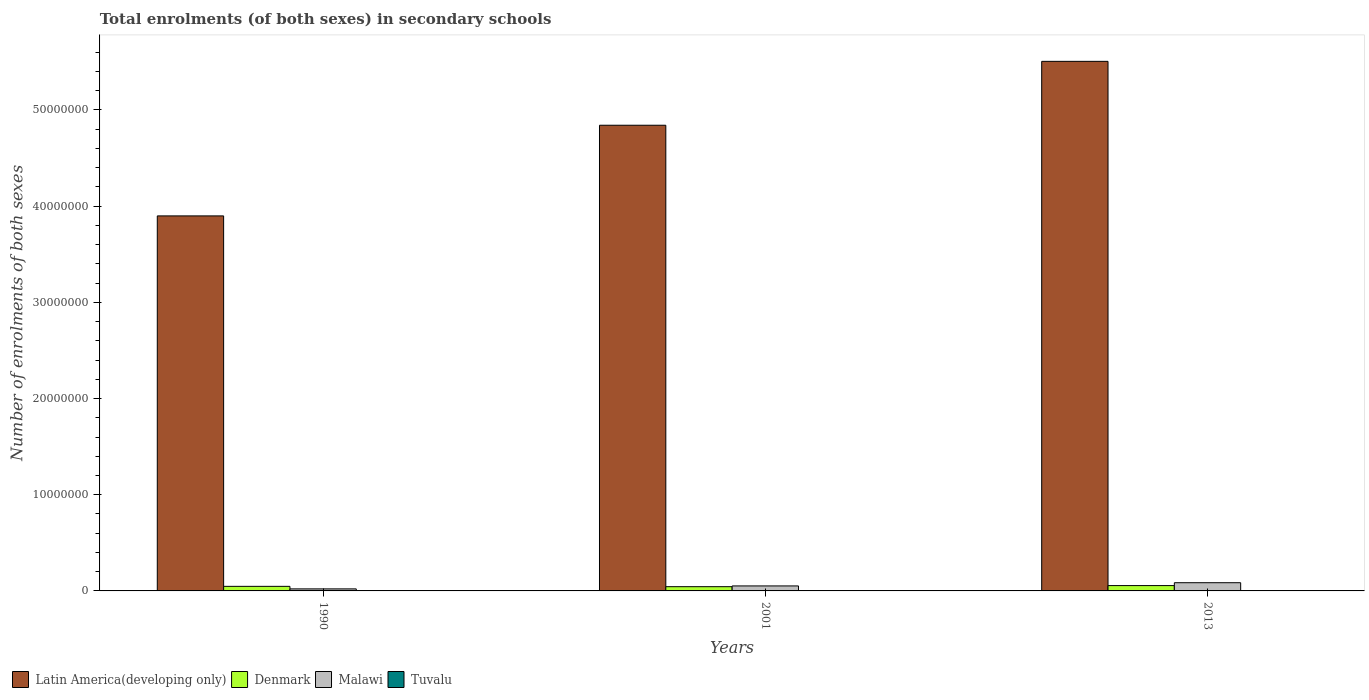How many different coloured bars are there?
Keep it short and to the point. 4. Are the number of bars on each tick of the X-axis equal?
Keep it short and to the point. Yes. How many bars are there on the 2nd tick from the left?
Keep it short and to the point. 4. How many bars are there on the 2nd tick from the right?
Your response must be concise. 4. What is the label of the 2nd group of bars from the left?
Offer a terse response. 2001. What is the number of enrolments in secondary schools in Malawi in 2001?
Provide a short and direct response. 5.18e+05. Across all years, what is the maximum number of enrolments in secondary schools in Malawi?
Offer a very short reply. 8.53e+05. Across all years, what is the minimum number of enrolments in secondary schools in Malawi?
Provide a succinct answer. 2.12e+05. In which year was the number of enrolments in secondary schools in Malawi minimum?
Make the answer very short. 1990. What is the total number of enrolments in secondary schools in Denmark in the graph?
Ensure brevity in your answer.  1.47e+06. What is the difference between the number of enrolments in secondary schools in Malawi in 1990 and that in 2013?
Keep it short and to the point. -6.41e+05. What is the difference between the number of enrolments in secondary schools in Denmark in 2001 and the number of enrolments in secondary schools in Malawi in 1990?
Offer a terse response. 2.29e+05. What is the average number of enrolments in secondary schools in Tuvalu per year?
Keep it short and to the point. 915.33. In the year 1990, what is the difference between the number of enrolments in secondary schools in Tuvalu and number of enrolments in secondary schools in Denmark?
Ensure brevity in your answer.  -4.74e+05. In how many years, is the number of enrolments in secondary schools in Denmark greater than 38000000?
Provide a succinct answer. 0. What is the ratio of the number of enrolments in secondary schools in Malawi in 2001 to that in 2013?
Provide a succinct answer. 0.61. What is the difference between the highest and the second highest number of enrolments in secondary schools in Latin America(developing only)?
Give a very brief answer. 6.64e+06. What is the difference between the highest and the lowest number of enrolments in secondary schools in Malawi?
Make the answer very short. 6.41e+05. In how many years, is the number of enrolments in secondary schools in Tuvalu greater than the average number of enrolments in secondary schools in Tuvalu taken over all years?
Provide a short and direct response. 1. What does the 4th bar from the right in 1990 represents?
Make the answer very short. Latin America(developing only). Is it the case that in every year, the sum of the number of enrolments in secondary schools in Latin America(developing only) and number of enrolments in secondary schools in Malawi is greater than the number of enrolments in secondary schools in Denmark?
Provide a succinct answer. Yes. How many years are there in the graph?
Your answer should be very brief. 3. What is the difference between two consecutive major ticks on the Y-axis?
Offer a terse response. 1.00e+07. Are the values on the major ticks of Y-axis written in scientific E-notation?
Offer a terse response. No. Does the graph contain any zero values?
Your answer should be very brief. No. Does the graph contain grids?
Give a very brief answer. No. Where does the legend appear in the graph?
Make the answer very short. Bottom left. How are the legend labels stacked?
Your response must be concise. Horizontal. What is the title of the graph?
Offer a terse response. Total enrolments (of both sexes) in secondary schools. What is the label or title of the X-axis?
Offer a terse response. Years. What is the label or title of the Y-axis?
Give a very brief answer. Number of enrolments of both sexes. What is the Number of enrolments of both sexes of Latin America(developing only) in 1990?
Provide a short and direct response. 3.90e+07. What is the Number of enrolments of both sexes in Denmark in 1990?
Ensure brevity in your answer.  4.75e+05. What is the Number of enrolments of both sexes of Malawi in 1990?
Keep it short and to the point. 2.12e+05. What is the Number of enrolments of both sexes of Tuvalu in 1990?
Your answer should be very brief. 625. What is the Number of enrolments of both sexes in Latin America(developing only) in 2001?
Make the answer very short. 4.84e+07. What is the Number of enrolments of both sexes in Denmark in 2001?
Keep it short and to the point. 4.42e+05. What is the Number of enrolments of both sexes of Malawi in 2001?
Provide a succinct answer. 5.18e+05. What is the Number of enrolments of both sexes in Tuvalu in 2001?
Give a very brief answer. 912. What is the Number of enrolments of both sexes in Latin America(developing only) in 2013?
Keep it short and to the point. 5.51e+07. What is the Number of enrolments of both sexes of Denmark in 2013?
Make the answer very short. 5.55e+05. What is the Number of enrolments of both sexes in Malawi in 2013?
Ensure brevity in your answer.  8.53e+05. What is the Number of enrolments of both sexes in Tuvalu in 2013?
Provide a succinct answer. 1209. Across all years, what is the maximum Number of enrolments of both sexes in Latin America(developing only)?
Ensure brevity in your answer.  5.51e+07. Across all years, what is the maximum Number of enrolments of both sexes of Denmark?
Provide a succinct answer. 5.55e+05. Across all years, what is the maximum Number of enrolments of both sexes of Malawi?
Your response must be concise. 8.53e+05. Across all years, what is the maximum Number of enrolments of both sexes of Tuvalu?
Give a very brief answer. 1209. Across all years, what is the minimum Number of enrolments of both sexes of Latin America(developing only)?
Ensure brevity in your answer.  3.90e+07. Across all years, what is the minimum Number of enrolments of both sexes of Denmark?
Your response must be concise. 4.42e+05. Across all years, what is the minimum Number of enrolments of both sexes in Malawi?
Your response must be concise. 2.12e+05. Across all years, what is the minimum Number of enrolments of both sexes of Tuvalu?
Provide a succinct answer. 625. What is the total Number of enrolments of both sexes in Latin America(developing only) in the graph?
Give a very brief answer. 1.42e+08. What is the total Number of enrolments of both sexes in Denmark in the graph?
Give a very brief answer. 1.47e+06. What is the total Number of enrolments of both sexes of Malawi in the graph?
Provide a short and direct response. 1.58e+06. What is the total Number of enrolments of both sexes in Tuvalu in the graph?
Your response must be concise. 2746. What is the difference between the Number of enrolments of both sexes of Latin America(developing only) in 1990 and that in 2001?
Your response must be concise. -9.42e+06. What is the difference between the Number of enrolments of both sexes of Denmark in 1990 and that in 2001?
Give a very brief answer. 3.34e+04. What is the difference between the Number of enrolments of both sexes in Malawi in 1990 and that in 2001?
Ensure brevity in your answer.  -3.06e+05. What is the difference between the Number of enrolments of both sexes of Tuvalu in 1990 and that in 2001?
Provide a succinct answer. -287. What is the difference between the Number of enrolments of both sexes in Latin America(developing only) in 1990 and that in 2013?
Your response must be concise. -1.61e+07. What is the difference between the Number of enrolments of both sexes in Denmark in 1990 and that in 2013?
Provide a short and direct response. -8.04e+04. What is the difference between the Number of enrolments of both sexes in Malawi in 1990 and that in 2013?
Keep it short and to the point. -6.41e+05. What is the difference between the Number of enrolments of both sexes in Tuvalu in 1990 and that in 2013?
Offer a very short reply. -584. What is the difference between the Number of enrolments of both sexes in Latin America(developing only) in 2001 and that in 2013?
Give a very brief answer. -6.64e+06. What is the difference between the Number of enrolments of both sexes of Denmark in 2001 and that in 2013?
Offer a terse response. -1.14e+05. What is the difference between the Number of enrolments of both sexes of Malawi in 2001 and that in 2013?
Your answer should be compact. -3.35e+05. What is the difference between the Number of enrolments of both sexes in Tuvalu in 2001 and that in 2013?
Your response must be concise. -297. What is the difference between the Number of enrolments of both sexes of Latin America(developing only) in 1990 and the Number of enrolments of both sexes of Denmark in 2001?
Offer a very short reply. 3.85e+07. What is the difference between the Number of enrolments of both sexes of Latin America(developing only) in 1990 and the Number of enrolments of both sexes of Malawi in 2001?
Your answer should be very brief. 3.85e+07. What is the difference between the Number of enrolments of both sexes in Latin America(developing only) in 1990 and the Number of enrolments of both sexes in Tuvalu in 2001?
Offer a very short reply. 3.90e+07. What is the difference between the Number of enrolments of both sexes in Denmark in 1990 and the Number of enrolments of both sexes in Malawi in 2001?
Ensure brevity in your answer.  -4.33e+04. What is the difference between the Number of enrolments of both sexes of Denmark in 1990 and the Number of enrolments of both sexes of Tuvalu in 2001?
Make the answer very short. 4.74e+05. What is the difference between the Number of enrolments of both sexes in Malawi in 1990 and the Number of enrolments of both sexes in Tuvalu in 2001?
Provide a short and direct response. 2.11e+05. What is the difference between the Number of enrolments of both sexes of Latin America(developing only) in 1990 and the Number of enrolments of both sexes of Denmark in 2013?
Give a very brief answer. 3.84e+07. What is the difference between the Number of enrolments of both sexes of Latin America(developing only) in 1990 and the Number of enrolments of both sexes of Malawi in 2013?
Provide a succinct answer. 3.81e+07. What is the difference between the Number of enrolments of both sexes in Latin America(developing only) in 1990 and the Number of enrolments of both sexes in Tuvalu in 2013?
Offer a terse response. 3.90e+07. What is the difference between the Number of enrolments of both sexes of Denmark in 1990 and the Number of enrolments of both sexes of Malawi in 2013?
Offer a very short reply. -3.78e+05. What is the difference between the Number of enrolments of both sexes of Denmark in 1990 and the Number of enrolments of both sexes of Tuvalu in 2013?
Make the answer very short. 4.74e+05. What is the difference between the Number of enrolments of both sexes of Malawi in 1990 and the Number of enrolments of both sexes of Tuvalu in 2013?
Your answer should be compact. 2.11e+05. What is the difference between the Number of enrolments of both sexes of Latin America(developing only) in 2001 and the Number of enrolments of both sexes of Denmark in 2013?
Your answer should be compact. 4.79e+07. What is the difference between the Number of enrolments of both sexes in Latin America(developing only) in 2001 and the Number of enrolments of both sexes in Malawi in 2013?
Your answer should be very brief. 4.76e+07. What is the difference between the Number of enrolments of both sexes of Latin America(developing only) in 2001 and the Number of enrolments of both sexes of Tuvalu in 2013?
Make the answer very short. 4.84e+07. What is the difference between the Number of enrolments of both sexes of Denmark in 2001 and the Number of enrolments of both sexes of Malawi in 2013?
Provide a short and direct response. -4.12e+05. What is the difference between the Number of enrolments of both sexes in Denmark in 2001 and the Number of enrolments of both sexes in Tuvalu in 2013?
Provide a succinct answer. 4.40e+05. What is the difference between the Number of enrolments of both sexes in Malawi in 2001 and the Number of enrolments of both sexes in Tuvalu in 2013?
Your answer should be very brief. 5.17e+05. What is the average Number of enrolments of both sexes of Latin America(developing only) per year?
Your answer should be very brief. 4.75e+07. What is the average Number of enrolments of both sexes in Denmark per year?
Make the answer very short. 4.91e+05. What is the average Number of enrolments of both sexes in Malawi per year?
Keep it short and to the point. 5.28e+05. What is the average Number of enrolments of both sexes in Tuvalu per year?
Your answer should be very brief. 915.33. In the year 1990, what is the difference between the Number of enrolments of both sexes of Latin America(developing only) and Number of enrolments of both sexes of Denmark?
Your answer should be compact. 3.85e+07. In the year 1990, what is the difference between the Number of enrolments of both sexes in Latin America(developing only) and Number of enrolments of both sexes in Malawi?
Offer a terse response. 3.88e+07. In the year 1990, what is the difference between the Number of enrolments of both sexes in Latin America(developing only) and Number of enrolments of both sexes in Tuvalu?
Your answer should be very brief. 3.90e+07. In the year 1990, what is the difference between the Number of enrolments of both sexes of Denmark and Number of enrolments of both sexes of Malawi?
Ensure brevity in your answer.  2.63e+05. In the year 1990, what is the difference between the Number of enrolments of both sexes in Denmark and Number of enrolments of both sexes in Tuvalu?
Provide a succinct answer. 4.74e+05. In the year 1990, what is the difference between the Number of enrolments of both sexes of Malawi and Number of enrolments of both sexes of Tuvalu?
Ensure brevity in your answer.  2.11e+05. In the year 2001, what is the difference between the Number of enrolments of both sexes in Latin America(developing only) and Number of enrolments of both sexes in Denmark?
Your answer should be compact. 4.80e+07. In the year 2001, what is the difference between the Number of enrolments of both sexes of Latin America(developing only) and Number of enrolments of both sexes of Malawi?
Your response must be concise. 4.79e+07. In the year 2001, what is the difference between the Number of enrolments of both sexes in Latin America(developing only) and Number of enrolments of both sexes in Tuvalu?
Your answer should be compact. 4.84e+07. In the year 2001, what is the difference between the Number of enrolments of both sexes in Denmark and Number of enrolments of both sexes in Malawi?
Provide a short and direct response. -7.67e+04. In the year 2001, what is the difference between the Number of enrolments of both sexes of Denmark and Number of enrolments of both sexes of Tuvalu?
Give a very brief answer. 4.41e+05. In the year 2001, what is the difference between the Number of enrolments of both sexes in Malawi and Number of enrolments of both sexes in Tuvalu?
Make the answer very short. 5.17e+05. In the year 2013, what is the difference between the Number of enrolments of both sexes in Latin America(developing only) and Number of enrolments of both sexes in Denmark?
Your response must be concise. 5.45e+07. In the year 2013, what is the difference between the Number of enrolments of both sexes of Latin America(developing only) and Number of enrolments of both sexes of Malawi?
Offer a very short reply. 5.42e+07. In the year 2013, what is the difference between the Number of enrolments of both sexes of Latin America(developing only) and Number of enrolments of both sexes of Tuvalu?
Provide a succinct answer. 5.51e+07. In the year 2013, what is the difference between the Number of enrolments of both sexes of Denmark and Number of enrolments of both sexes of Malawi?
Offer a terse response. -2.98e+05. In the year 2013, what is the difference between the Number of enrolments of both sexes of Denmark and Number of enrolments of both sexes of Tuvalu?
Your answer should be very brief. 5.54e+05. In the year 2013, what is the difference between the Number of enrolments of both sexes in Malawi and Number of enrolments of both sexes in Tuvalu?
Give a very brief answer. 8.52e+05. What is the ratio of the Number of enrolments of both sexes of Latin America(developing only) in 1990 to that in 2001?
Ensure brevity in your answer.  0.81. What is the ratio of the Number of enrolments of both sexes in Denmark in 1990 to that in 2001?
Provide a short and direct response. 1.08. What is the ratio of the Number of enrolments of both sexes in Malawi in 1990 to that in 2001?
Offer a terse response. 0.41. What is the ratio of the Number of enrolments of both sexes of Tuvalu in 1990 to that in 2001?
Give a very brief answer. 0.69. What is the ratio of the Number of enrolments of both sexes in Latin America(developing only) in 1990 to that in 2013?
Offer a very short reply. 0.71. What is the ratio of the Number of enrolments of both sexes of Denmark in 1990 to that in 2013?
Your response must be concise. 0.86. What is the ratio of the Number of enrolments of both sexes in Malawi in 1990 to that in 2013?
Provide a succinct answer. 0.25. What is the ratio of the Number of enrolments of both sexes of Tuvalu in 1990 to that in 2013?
Your answer should be compact. 0.52. What is the ratio of the Number of enrolments of both sexes in Latin America(developing only) in 2001 to that in 2013?
Make the answer very short. 0.88. What is the ratio of the Number of enrolments of both sexes of Denmark in 2001 to that in 2013?
Your answer should be very brief. 0.8. What is the ratio of the Number of enrolments of both sexes of Malawi in 2001 to that in 2013?
Ensure brevity in your answer.  0.61. What is the ratio of the Number of enrolments of both sexes in Tuvalu in 2001 to that in 2013?
Make the answer very short. 0.75. What is the difference between the highest and the second highest Number of enrolments of both sexes of Latin America(developing only)?
Provide a short and direct response. 6.64e+06. What is the difference between the highest and the second highest Number of enrolments of both sexes of Denmark?
Your answer should be compact. 8.04e+04. What is the difference between the highest and the second highest Number of enrolments of both sexes of Malawi?
Give a very brief answer. 3.35e+05. What is the difference between the highest and the second highest Number of enrolments of both sexes of Tuvalu?
Offer a very short reply. 297. What is the difference between the highest and the lowest Number of enrolments of both sexes in Latin America(developing only)?
Your answer should be very brief. 1.61e+07. What is the difference between the highest and the lowest Number of enrolments of both sexes of Denmark?
Your answer should be compact. 1.14e+05. What is the difference between the highest and the lowest Number of enrolments of both sexes of Malawi?
Your answer should be compact. 6.41e+05. What is the difference between the highest and the lowest Number of enrolments of both sexes of Tuvalu?
Make the answer very short. 584. 